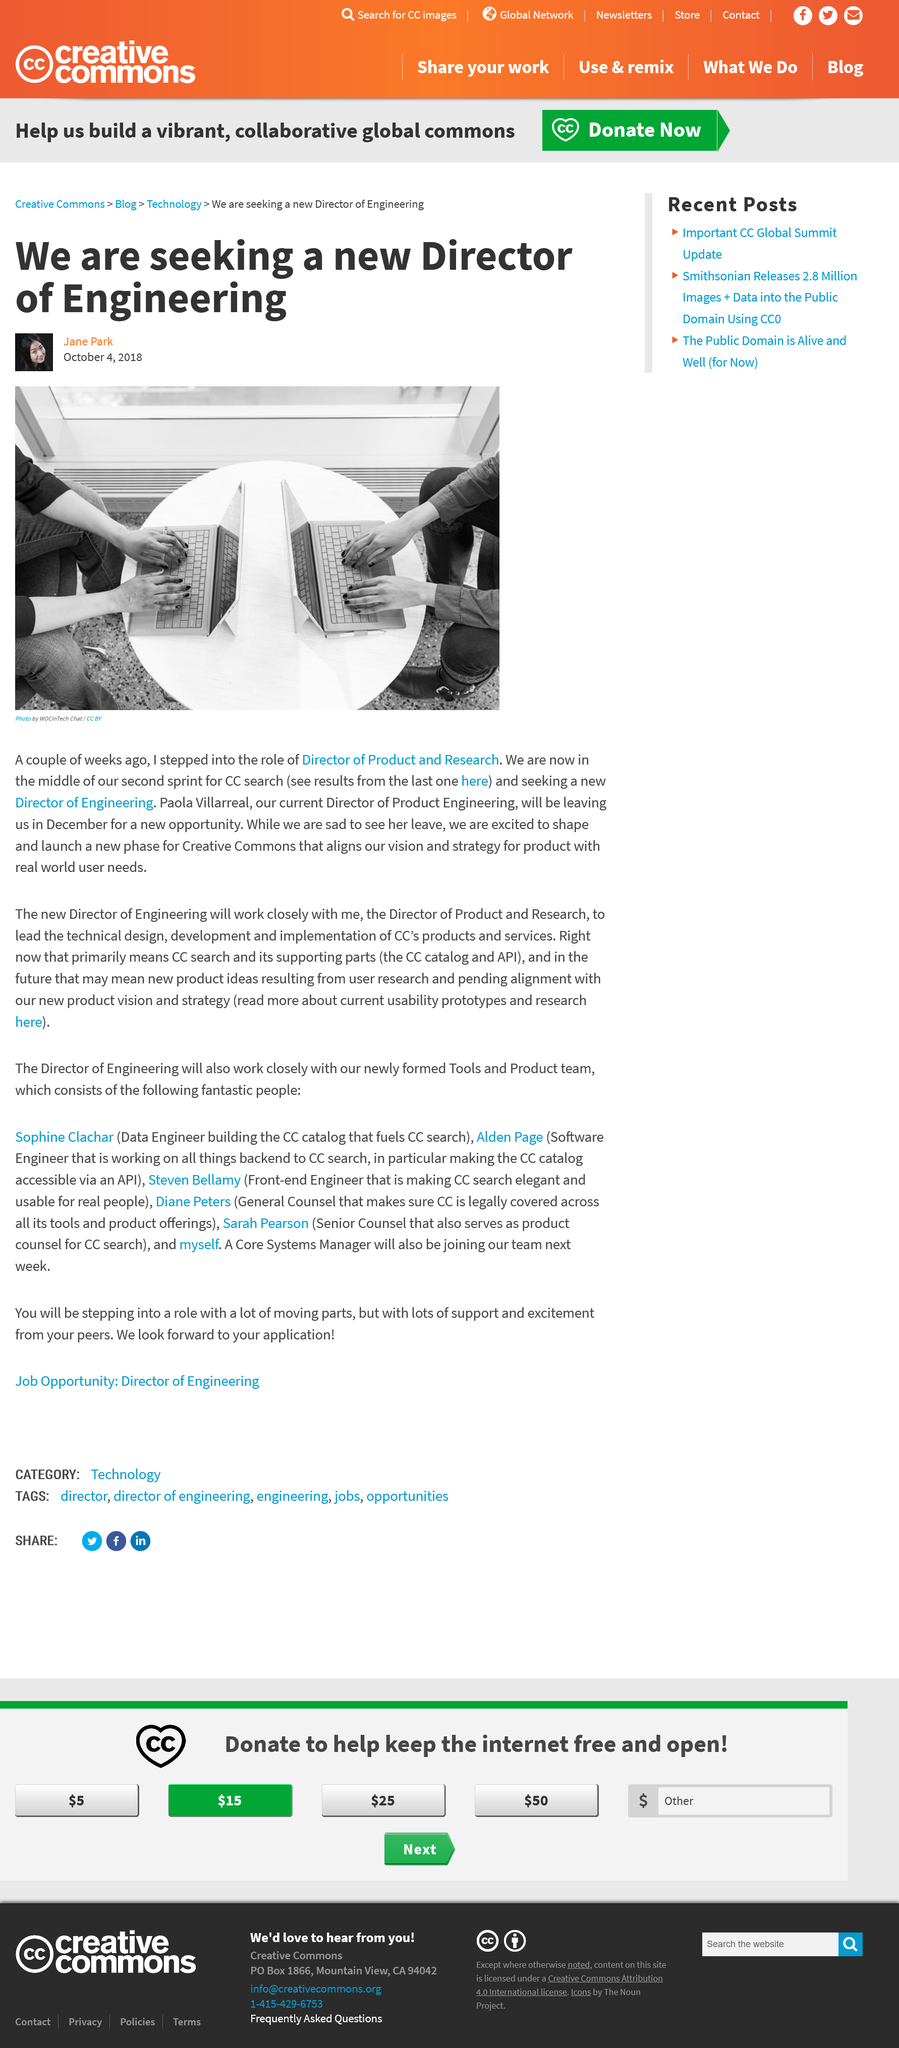Draw attention to some important aspects in this diagram. Creative Commons is seeking a new Director of Engineering to join its organization. Jane Park is the Director of Product and Research for Creative Commons. On October 4th, 2018, Paolo Villarreal was the Director of Product Engineering at Creative Commons. 